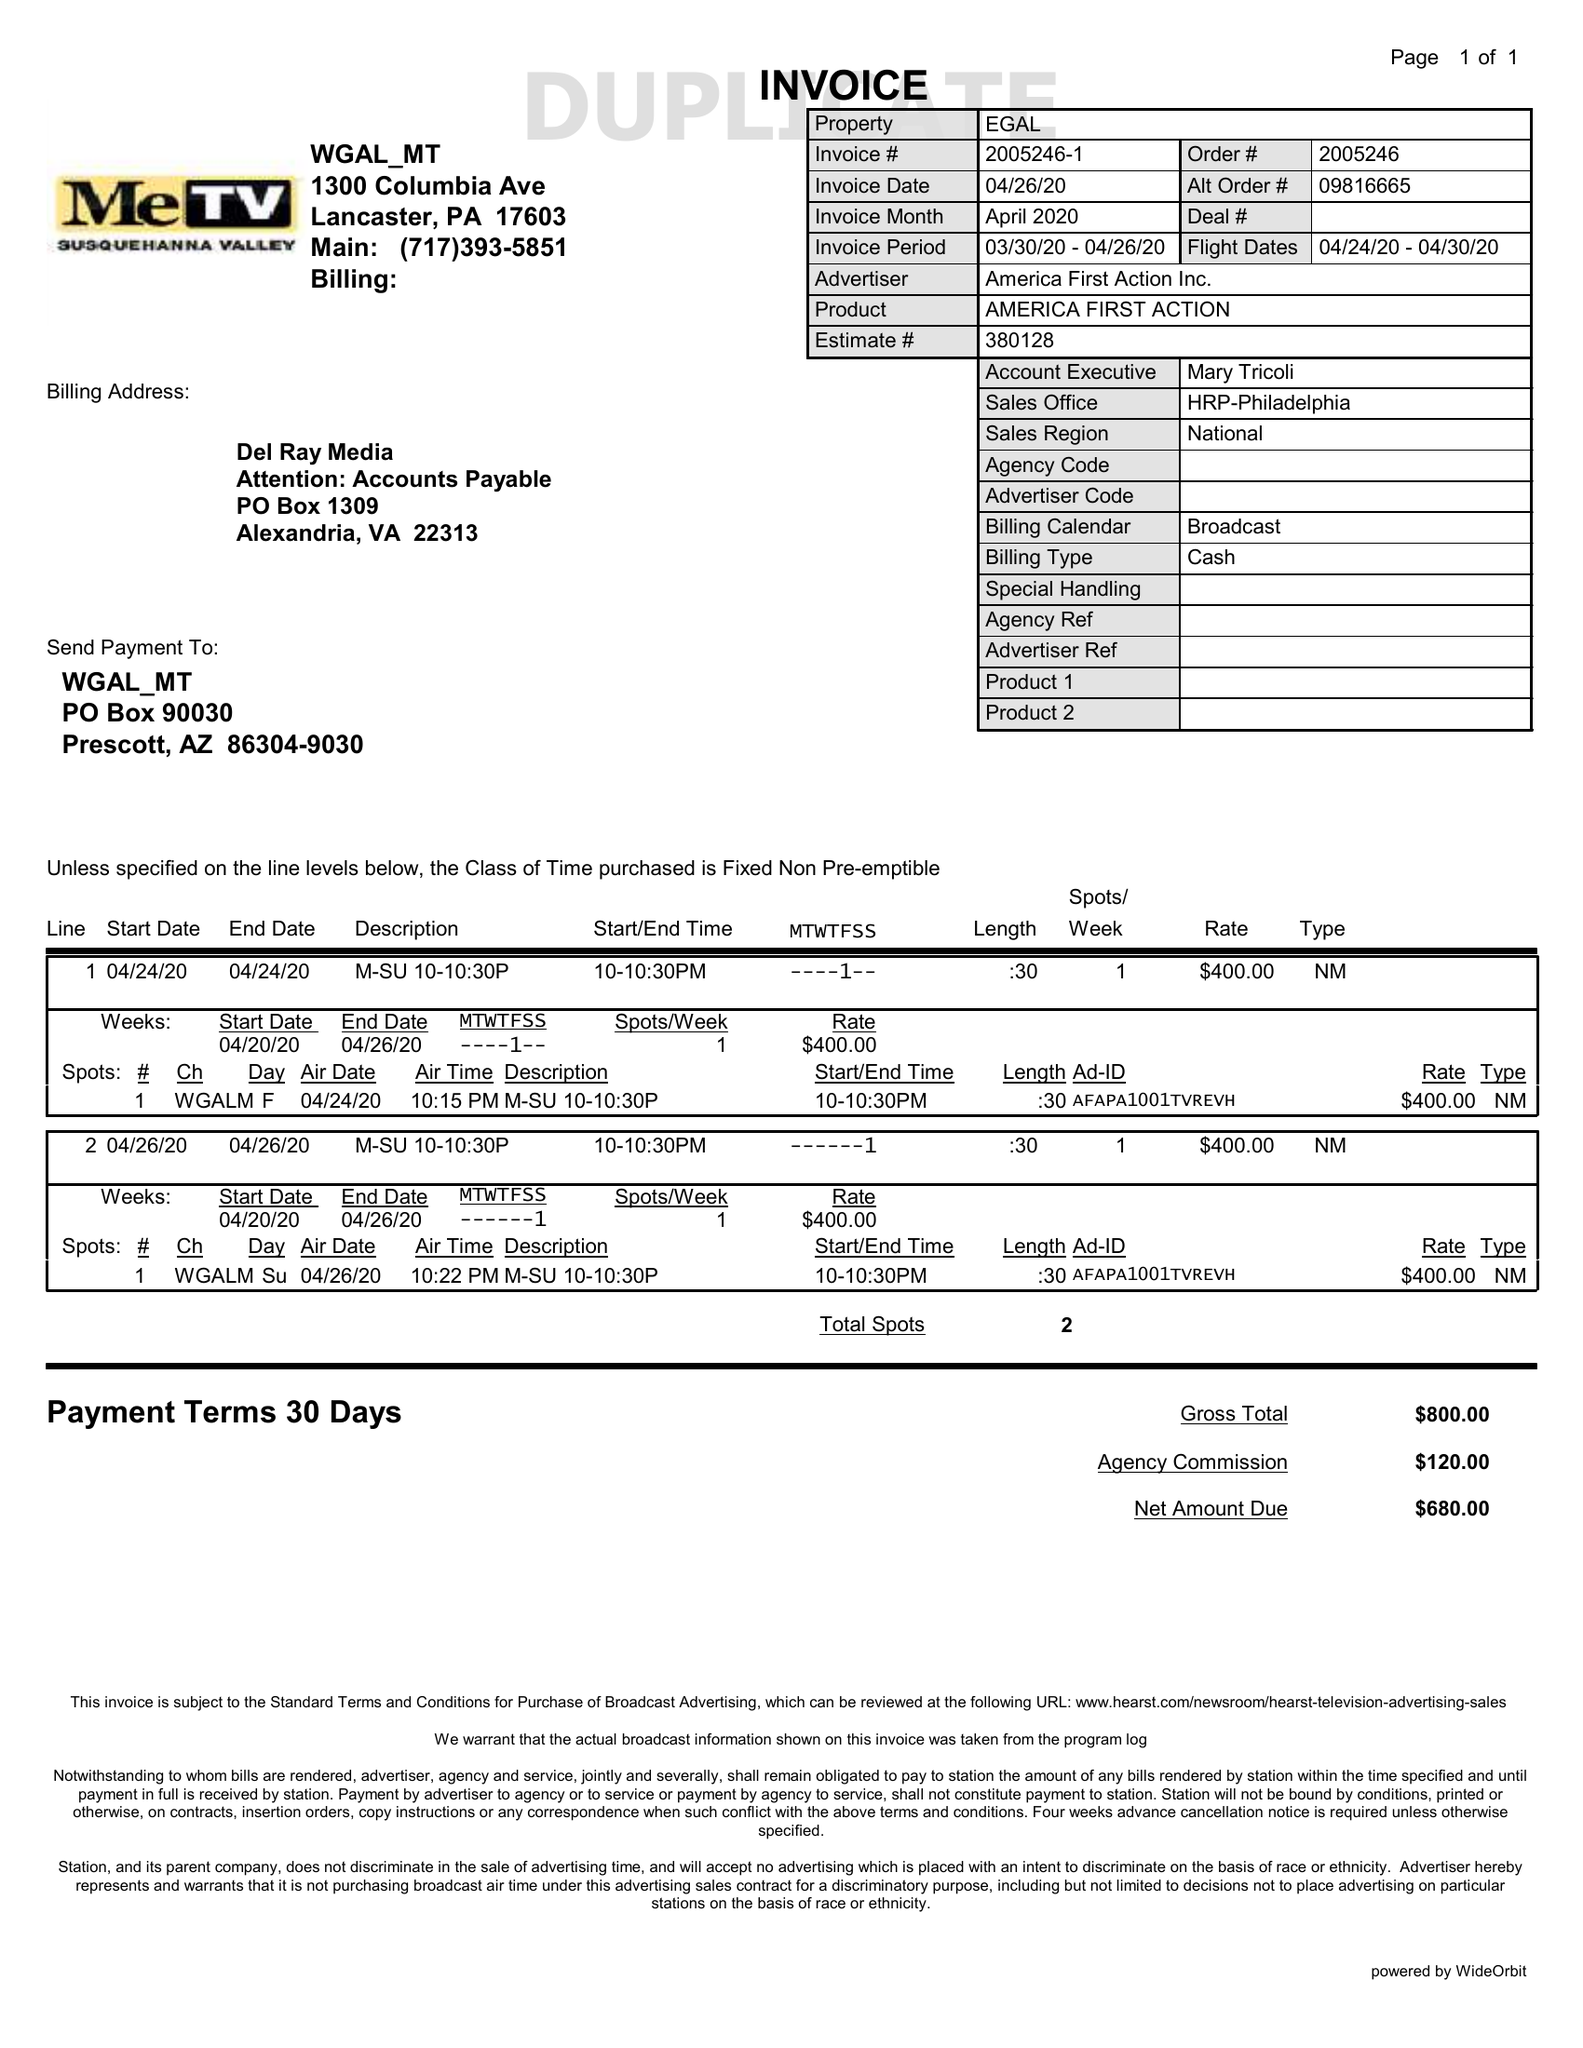What is the value for the contract_num?
Answer the question using a single word or phrase. 2005246 